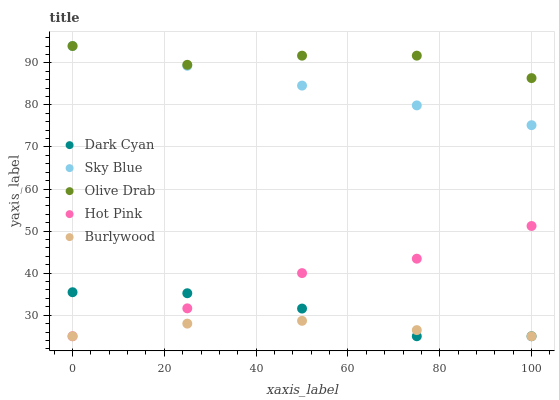Does Burlywood have the minimum area under the curve?
Answer yes or no. Yes. Does Olive Drab have the maximum area under the curve?
Answer yes or no. Yes. Does Sky Blue have the minimum area under the curve?
Answer yes or no. No. Does Sky Blue have the maximum area under the curve?
Answer yes or no. No. Is Sky Blue the smoothest?
Answer yes or no. Yes. Is Olive Drab the roughest?
Answer yes or no. Yes. Is Hot Pink the smoothest?
Answer yes or no. No. Is Hot Pink the roughest?
Answer yes or no. No. Does Dark Cyan have the lowest value?
Answer yes or no. Yes. Does Sky Blue have the lowest value?
Answer yes or no. No. Does Olive Drab have the highest value?
Answer yes or no. Yes. Does Hot Pink have the highest value?
Answer yes or no. No. Is Burlywood less than Olive Drab?
Answer yes or no. Yes. Is Sky Blue greater than Dark Cyan?
Answer yes or no. Yes. Does Hot Pink intersect Burlywood?
Answer yes or no. Yes. Is Hot Pink less than Burlywood?
Answer yes or no. No. Is Hot Pink greater than Burlywood?
Answer yes or no. No. Does Burlywood intersect Olive Drab?
Answer yes or no. No. 